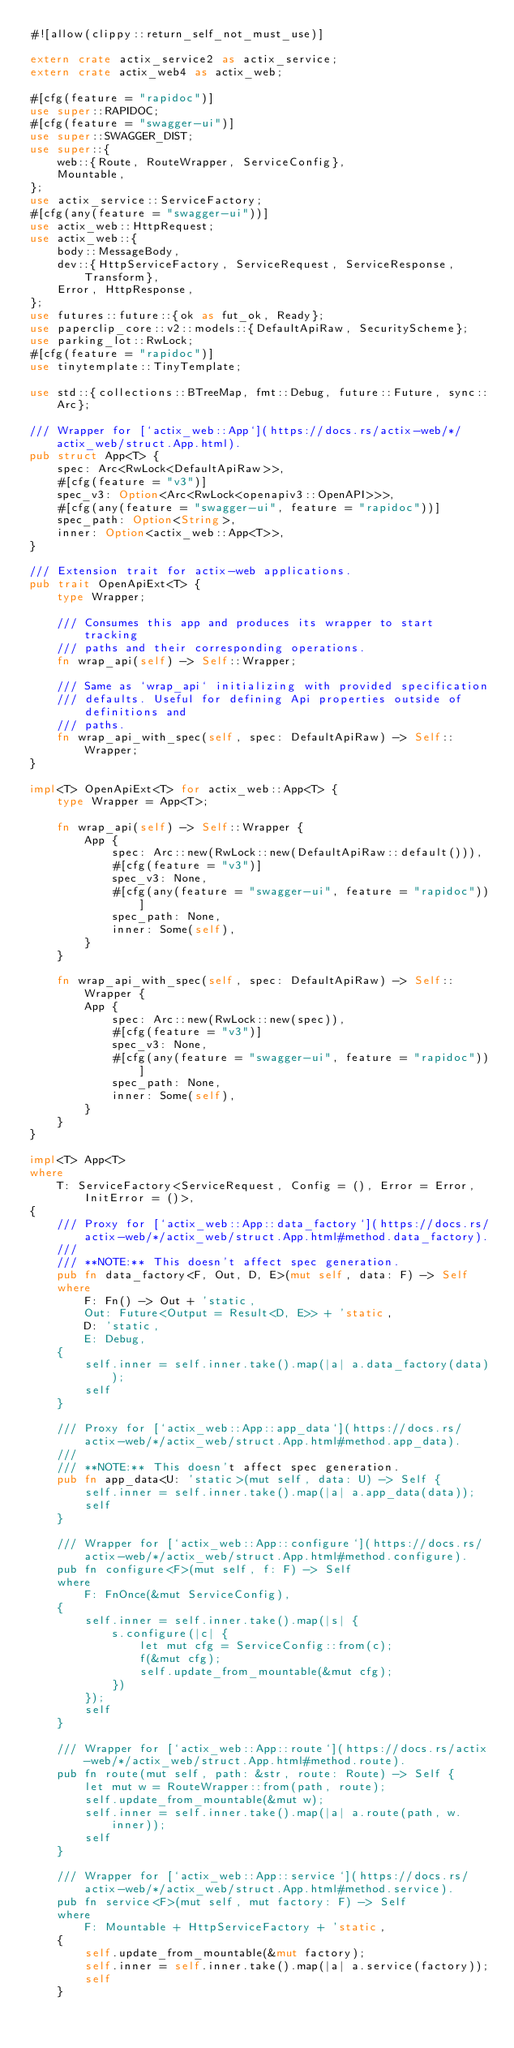Convert code to text. <code><loc_0><loc_0><loc_500><loc_500><_Rust_>#![allow(clippy::return_self_not_must_use)]

extern crate actix_service2 as actix_service;
extern crate actix_web4 as actix_web;

#[cfg(feature = "rapidoc")]
use super::RAPIDOC;
#[cfg(feature = "swagger-ui")]
use super::SWAGGER_DIST;
use super::{
    web::{Route, RouteWrapper, ServiceConfig},
    Mountable,
};
use actix_service::ServiceFactory;
#[cfg(any(feature = "swagger-ui"))]
use actix_web::HttpRequest;
use actix_web::{
    body::MessageBody,
    dev::{HttpServiceFactory, ServiceRequest, ServiceResponse, Transform},
    Error, HttpResponse,
};
use futures::future::{ok as fut_ok, Ready};
use paperclip_core::v2::models::{DefaultApiRaw, SecurityScheme};
use parking_lot::RwLock;
#[cfg(feature = "rapidoc")]
use tinytemplate::TinyTemplate;

use std::{collections::BTreeMap, fmt::Debug, future::Future, sync::Arc};

/// Wrapper for [`actix_web::App`](https://docs.rs/actix-web/*/actix_web/struct.App.html).
pub struct App<T> {
    spec: Arc<RwLock<DefaultApiRaw>>,
    #[cfg(feature = "v3")]
    spec_v3: Option<Arc<RwLock<openapiv3::OpenAPI>>>,
    #[cfg(any(feature = "swagger-ui", feature = "rapidoc"))]
    spec_path: Option<String>,
    inner: Option<actix_web::App<T>>,
}

/// Extension trait for actix-web applications.
pub trait OpenApiExt<T> {
    type Wrapper;

    /// Consumes this app and produces its wrapper to start tracking
    /// paths and their corresponding operations.
    fn wrap_api(self) -> Self::Wrapper;

    /// Same as `wrap_api` initializing with provided specification
    /// defaults. Useful for defining Api properties outside of definitions and
    /// paths.
    fn wrap_api_with_spec(self, spec: DefaultApiRaw) -> Self::Wrapper;
}

impl<T> OpenApiExt<T> for actix_web::App<T> {
    type Wrapper = App<T>;

    fn wrap_api(self) -> Self::Wrapper {
        App {
            spec: Arc::new(RwLock::new(DefaultApiRaw::default())),
            #[cfg(feature = "v3")]
            spec_v3: None,
            #[cfg(any(feature = "swagger-ui", feature = "rapidoc"))]
            spec_path: None,
            inner: Some(self),
        }
    }

    fn wrap_api_with_spec(self, spec: DefaultApiRaw) -> Self::Wrapper {
        App {
            spec: Arc::new(RwLock::new(spec)),
            #[cfg(feature = "v3")]
            spec_v3: None,
            #[cfg(any(feature = "swagger-ui", feature = "rapidoc"))]
            spec_path: None,
            inner: Some(self),
        }
    }
}

impl<T> App<T>
where
    T: ServiceFactory<ServiceRequest, Config = (), Error = Error, InitError = ()>,
{
    /// Proxy for [`actix_web::App::data_factory`](https://docs.rs/actix-web/*/actix_web/struct.App.html#method.data_factory).
    ///
    /// **NOTE:** This doesn't affect spec generation.
    pub fn data_factory<F, Out, D, E>(mut self, data: F) -> Self
    where
        F: Fn() -> Out + 'static,
        Out: Future<Output = Result<D, E>> + 'static,
        D: 'static,
        E: Debug,
    {
        self.inner = self.inner.take().map(|a| a.data_factory(data));
        self
    }

    /// Proxy for [`actix_web::App::app_data`](https://docs.rs/actix-web/*/actix_web/struct.App.html#method.app_data).
    ///
    /// **NOTE:** This doesn't affect spec generation.
    pub fn app_data<U: 'static>(mut self, data: U) -> Self {
        self.inner = self.inner.take().map(|a| a.app_data(data));
        self
    }

    /// Wrapper for [`actix_web::App::configure`](https://docs.rs/actix-web/*/actix_web/struct.App.html#method.configure).
    pub fn configure<F>(mut self, f: F) -> Self
    where
        F: FnOnce(&mut ServiceConfig),
    {
        self.inner = self.inner.take().map(|s| {
            s.configure(|c| {
                let mut cfg = ServiceConfig::from(c);
                f(&mut cfg);
                self.update_from_mountable(&mut cfg);
            })
        });
        self
    }

    /// Wrapper for [`actix_web::App::route`](https://docs.rs/actix-web/*/actix_web/struct.App.html#method.route).
    pub fn route(mut self, path: &str, route: Route) -> Self {
        let mut w = RouteWrapper::from(path, route);
        self.update_from_mountable(&mut w);
        self.inner = self.inner.take().map(|a| a.route(path, w.inner));
        self
    }

    /// Wrapper for [`actix_web::App::service`](https://docs.rs/actix-web/*/actix_web/struct.App.html#method.service).
    pub fn service<F>(mut self, mut factory: F) -> Self
    where
        F: Mountable + HttpServiceFactory + 'static,
    {
        self.update_from_mountable(&mut factory);
        self.inner = self.inner.take().map(|a| a.service(factory));
        self
    }
</code> 